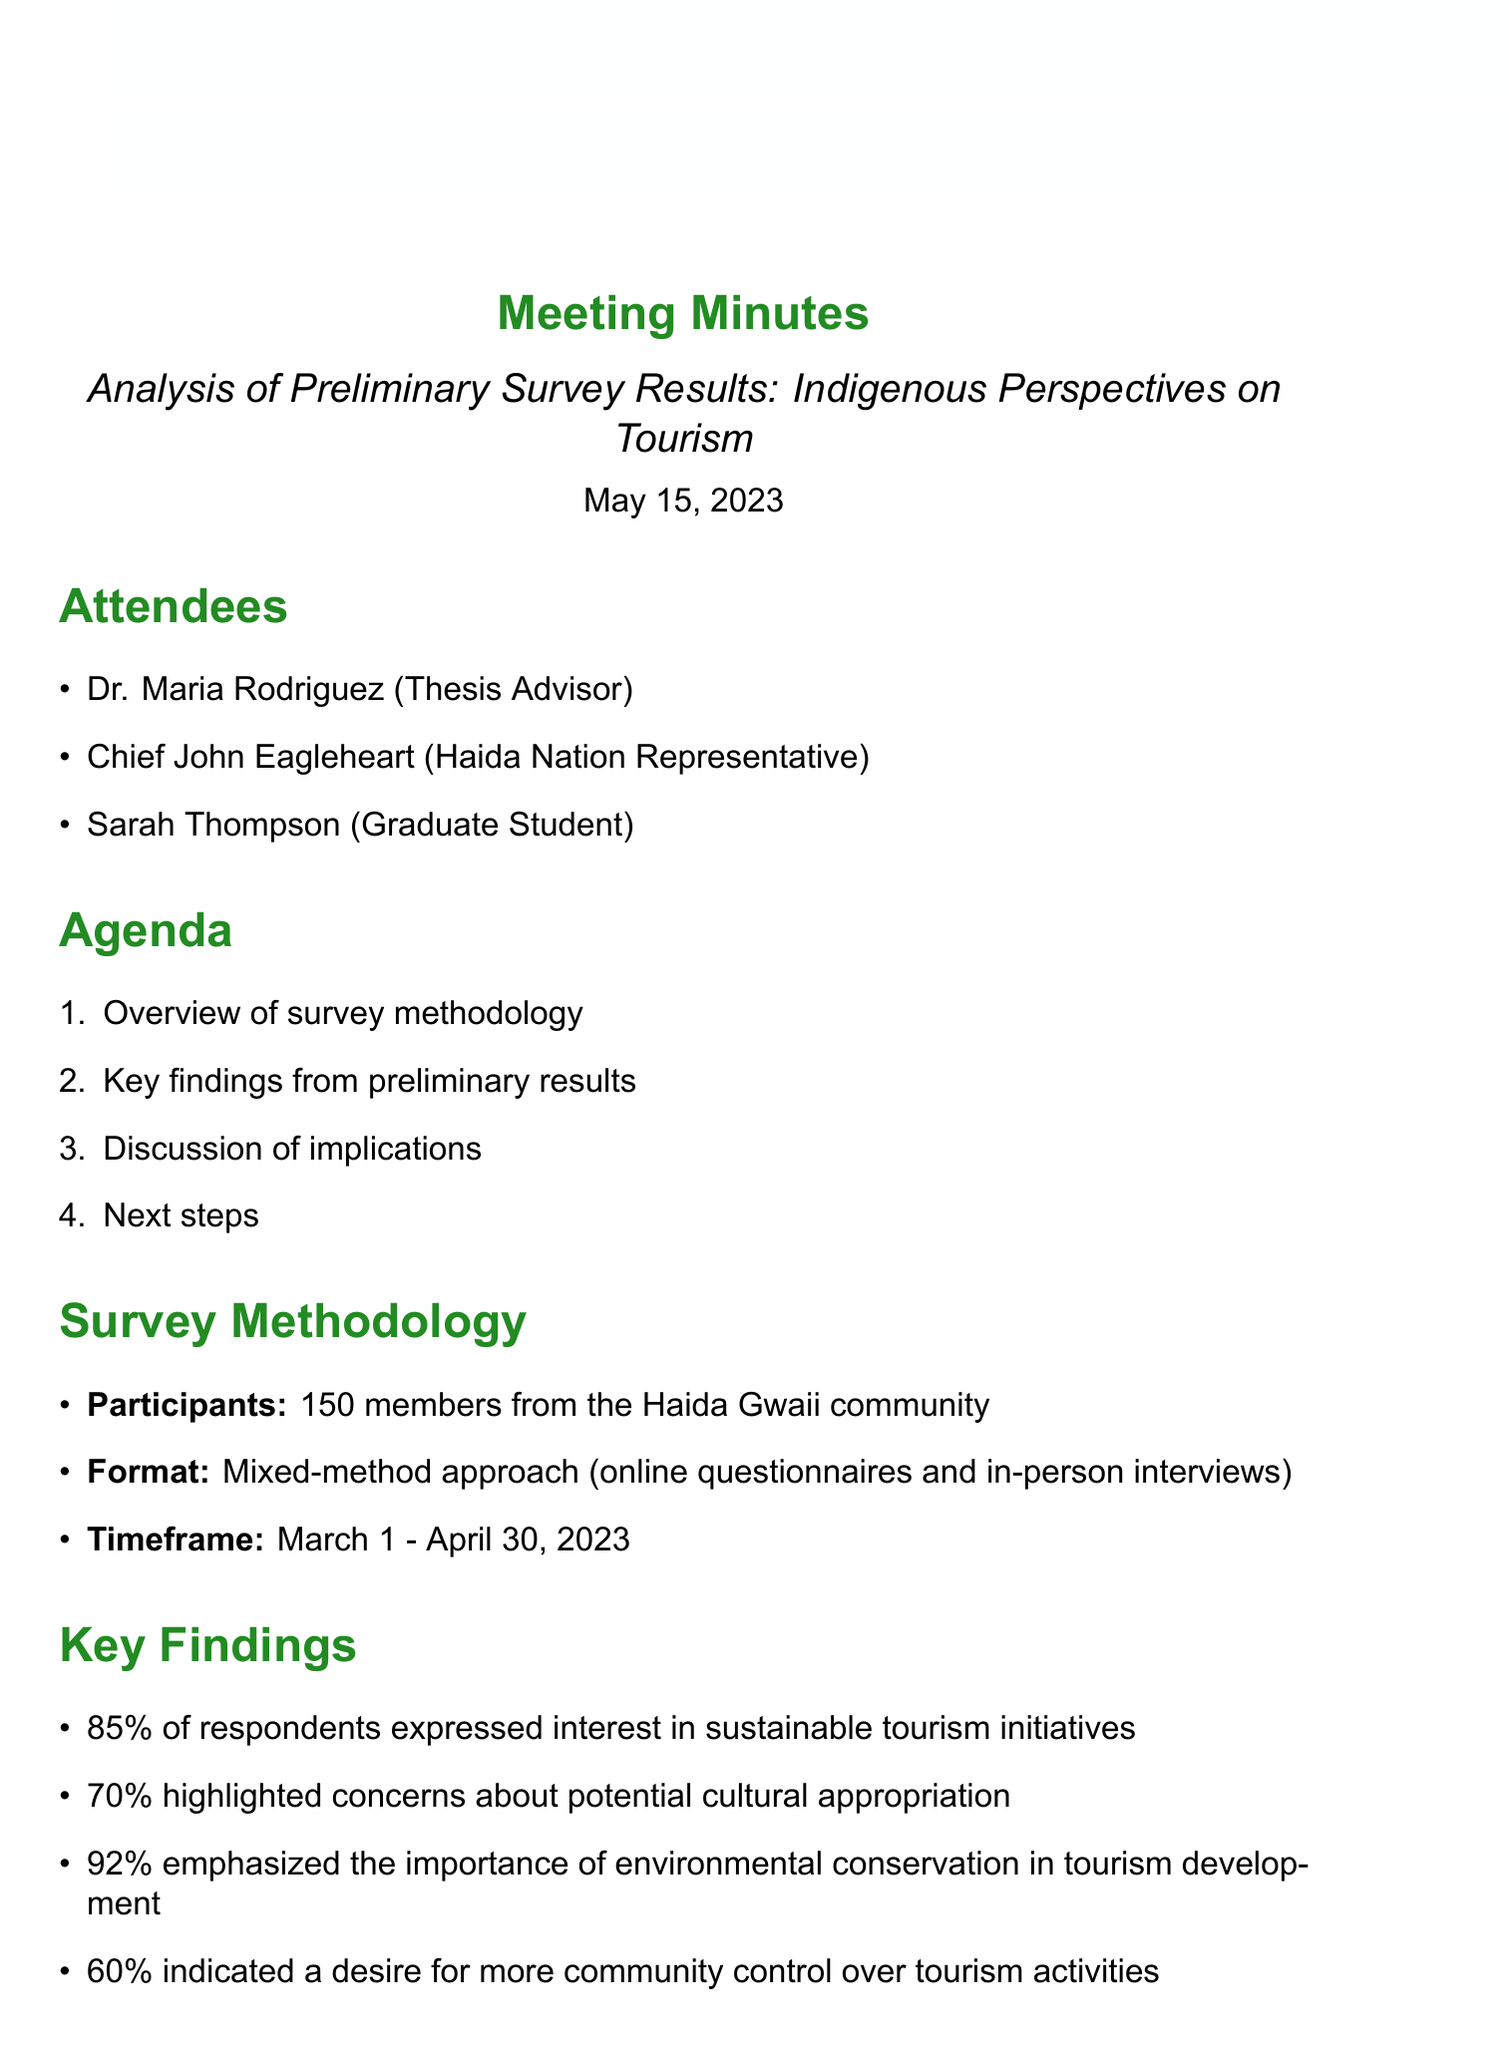what is the date of the meeting? The date of the meeting is listed in the document as May 15, 2023.
Answer: May 15, 2023 who is the Haida Nation Representative? The document states that Chief John Eagleheart is the Haida Nation Representative.
Answer: Chief John Eagleheart what percentage of respondents expressed interest in sustainable tourism initiatives? The percentage is found in the key findings section of the document, where it states that 85% expressed interest.
Answer: 85% how many members participated in the survey? The number of participants is specified in the survey methodology section, stating 150 members from the Haida Gwaii community participated.
Answer: 150 what are the next steps mentioned in the meeting? The document outlines several next steps, including conducting follow-up interviews with key community leaders.
Answer: Conduct follow-up interviews with key community leaders which concern was highlighted by 70% of respondents? The document states that 70% of respondents highlighted concerns about potential cultural appropriation.
Answer: Potential cultural appropriation what training programs are suggested in the discussion points? The discussion points indicate that training programs for local tour guides are suggested.
Answer: Training programs for local tour guides what was the timeframe for completing the survey? The timeframe is mentioned in the survey methodology section, indicating it was from March 1 to April 30, 2023.
Answer: March 1 - April 30, 2023 what is one theme discussed regarding tourism benefits? The document discusses balancing economic benefits and cultural preservation as a theme.
Answer: Balance between economic benefits and cultural preservation 